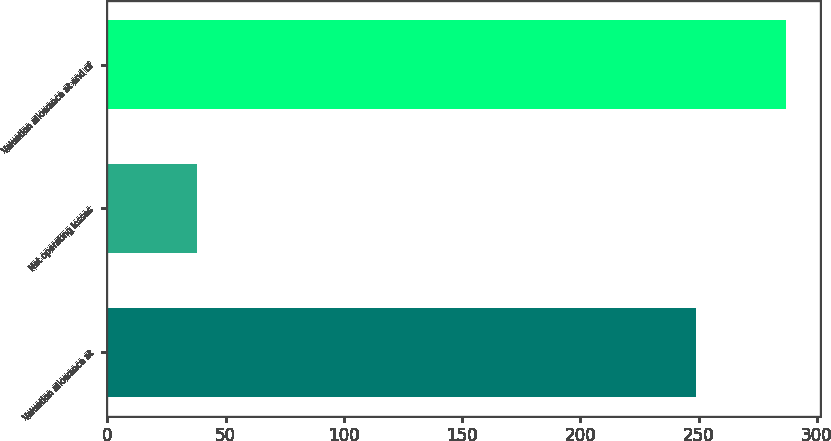<chart> <loc_0><loc_0><loc_500><loc_500><bar_chart><fcel>Valuation allowance at<fcel>Net operating losses<fcel>Valuation allowance at end of<nl><fcel>249<fcel>38<fcel>287<nl></chart> 